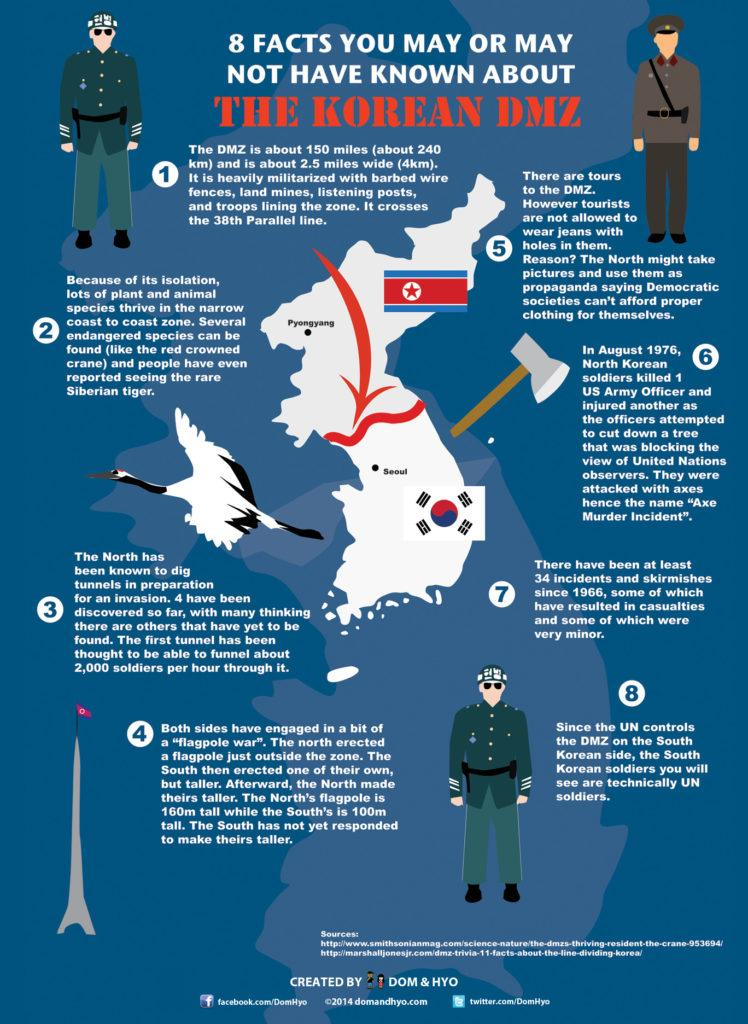Outline some significant characteristics in this image. The Northern tunnel can accommodate 2,000 soldiers per hour. On August 1976, in the United States Army, a officer was killed in an event known as the "Axe Murder Incident. The "Axe Murder Incident" involved the use of an axe as a weapon. The attack on the US officers in the Axe Murder Incident was carried out by North Korean soldiers. The DMZ is home to two endangered species, the red crowned crane and the Siberian tiger. These species are threatened due to various factors, including habitat loss and human activity. It is important to conserve and protect these species in order to ensure their survival. 